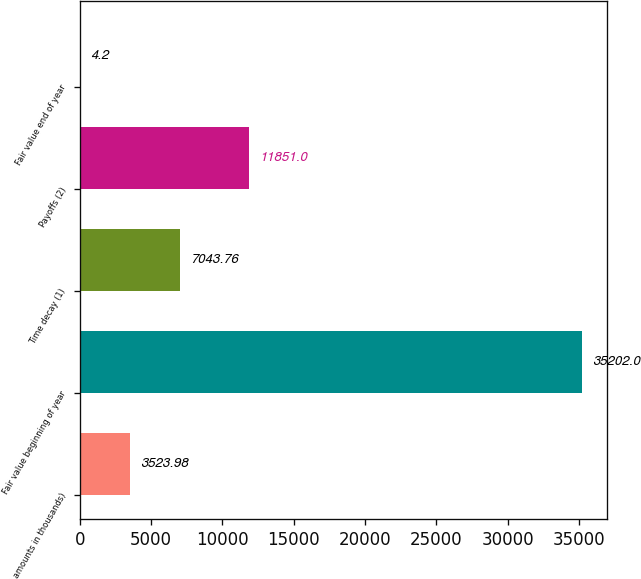Convert chart to OTSL. <chart><loc_0><loc_0><loc_500><loc_500><bar_chart><fcel>(dollar amounts in thousands)<fcel>Fair value beginning of year<fcel>Time decay (1)<fcel>Payoffs (2)<fcel>Fair value end of year<nl><fcel>3523.98<fcel>35202<fcel>7043.76<fcel>11851<fcel>4.2<nl></chart> 